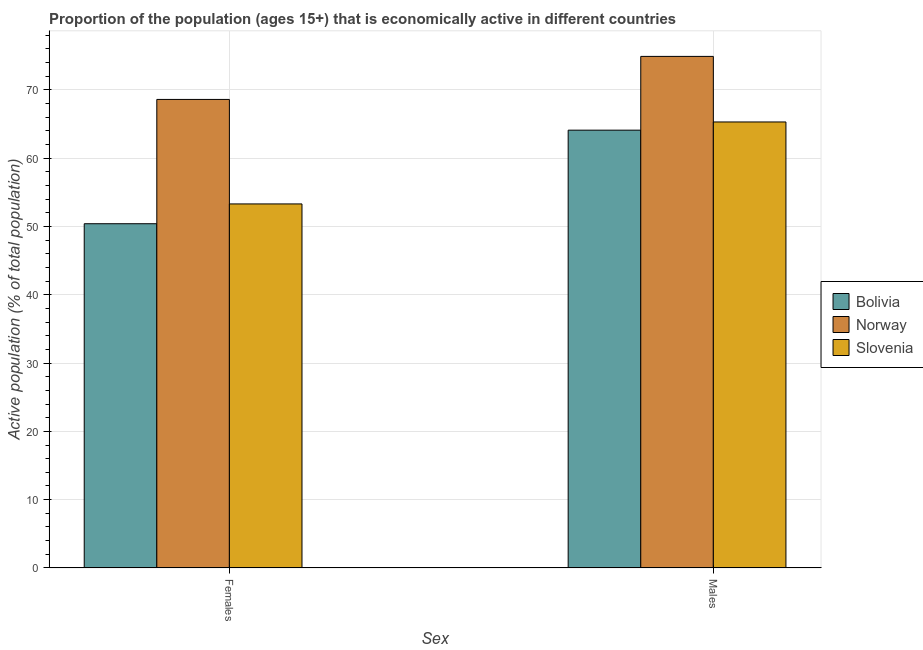How many groups of bars are there?
Your answer should be compact. 2. Are the number of bars per tick equal to the number of legend labels?
Provide a short and direct response. Yes. How many bars are there on the 2nd tick from the left?
Your answer should be compact. 3. What is the label of the 1st group of bars from the left?
Your response must be concise. Females. What is the percentage of economically active female population in Slovenia?
Give a very brief answer. 53.3. Across all countries, what is the maximum percentage of economically active female population?
Ensure brevity in your answer.  68.6. Across all countries, what is the minimum percentage of economically active female population?
Keep it short and to the point. 50.4. In which country was the percentage of economically active male population maximum?
Keep it short and to the point. Norway. In which country was the percentage of economically active female population minimum?
Provide a succinct answer. Bolivia. What is the total percentage of economically active female population in the graph?
Ensure brevity in your answer.  172.3. What is the difference between the percentage of economically active female population in Slovenia and that in Norway?
Offer a very short reply. -15.3. What is the difference between the percentage of economically active female population in Bolivia and the percentage of economically active male population in Norway?
Your answer should be compact. -24.5. What is the average percentage of economically active male population per country?
Ensure brevity in your answer.  68.1. What is the difference between the percentage of economically active male population and percentage of economically active female population in Bolivia?
Provide a short and direct response. 13.7. In how many countries, is the percentage of economically active female population greater than 52 %?
Make the answer very short. 2. What is the ratio of the percentage of economically active female population in Slovenia to that in Bolivia?
Your answer should be very brief. 1.06. Is the percentage of economically active female population in Bolivia less than that in Slovenia?
Keep it short and to the point. Yes. In how many countries, is the percentage of economically active male population greater than the average percentage of economically active male population taken over all countries?
Your answer should be compact. 1. What does the 3rd bar from the left in Males represents?
Provide a succinct answer. Slovenia. What does the 2nd bar from the right in Males represents?
Your response must be concise. Norway. How many countries are there in the graph?
Your answer should be very brief. 3. What is the difference between two consecutive major ticks on the Y-axis?
Offer a terse response. 10. Are the values on the major ticks of Y-axis written in scientific E-notation?
Provide a succinct answer. No. Does the graph contain grids?
Make the answer very short. Yes. What is the title of the graph?
Keep it short and to the point. Proportion of the population (ages 15+) that is economically active in different countries. Does "Peru" appear as one of the legend labels in the graph?
Provide a succinct answer. No. What is the label or title of the X-axis?
Offer a very short reply. Sex. What is the label or title of the Y-axis?
Provide a short and direct response. Active population (% of total population). What is the Active population (% of total population) of Bolivia in Females?
Your answer should be compact. 50.4. What is the Active population (% of total population) of Norway in Females?
Provide a short and direct response. 68.6. What is the Active population (% of total population) of Slovenia in Females?
Give a very brief answer. 53.3. What is the Active population (% of total population) of Bolivia in Males?
Keep it short and to the point. 64.1. What is the Active population (% of total population) of Norway in Males?
Your response must be concise. 74.9. What is the Active population (% of total population) in Slovenia in Males?
Provide a short and direct response. 65.3. Across all Sex, what is the maximum Active population (% of total population) in Bolivia?
Your answer should be very brief. 64.1. Across all Sex, what is the maximum Active population (% of total population) in Norway?
Your answer should be very brief. 74.9. Across all Sex, what is the maximum Active population (% of total population) in Slovenia?
Provide a succinct answer. 65.3. Across all Sex, what is the minimum Active population (% of total population) of Bolivia?
Your response must be concise. 50.4. Across all Sex, what is the minimum Active population (% of total population) of Norway?
Your answer should be very brief. 68.6. Across all Sex, what is the minimum Active population (% of total population) in Slovenia?
Your answer should be compact. 53.3. What is the total Active population (% of total population) in Bolivia in the graph?
Offer a terse response. 114.5. What is the total Active population (% of total population) of Norway in the graph?
Offer a terse response. 143.5. What is the total Active population (% of total population) of Slovenia in the graph?
Your response must be concise. 118.6. What is the difference between the Active population (% of total population) in Bolivia in Females and that in Males?
Make the answer very short. -13.7. What is the difference between the Active population (% of total population) of Bolivia in Females and the Active population (% of total population) of Norway in Males?
Ensure brevity in your answer.  -24.5. What is the difference between the Active population (% of total population) of Bolivia in Females and the Active population (% of total population) of Slovenia in Males?
Provide a succinct answer. -14.9. What is the difference between the Active population (% of total population) in Norway in Females and the Active population (% of total population) in Slovenia in Males?
Your answer should be very brief. 3.3. What is the average Active population (% of total population) in Bolivia per Sex?
Give a very brief answer. 57.25. What is the average Active population (% of total population) of Norway per Sex?
Your answer should be very brief. 71.75. What is the average Active population (% of total population) in Slovenia per Sex?
Your answer should be very brief. 59.3. What is the difference between the Active population (% of total population) in Bolivia and Active population (% of total population) in Norway in Females?
Keep it short and to the point. -18.2. What is the difference between the Active population (% of total population) of Bolivia and Active population (% of total population) of Slovenia in Females?
Give a very brief answer. -2.9. What is the difference between the Active population (% of total population) of Norway and Active population (% of total population) of Slovenia in Males?
Give a very brief answer. 9.6. What is the ratio of the Active population (% of total population) in Bolivia in Females to that in Males?
Ensure brevity in your answer.  0.79. What is the ratio of the Active population (% of total population) of Norway in Females to that in Males?
Make the answer very short. 0.92. What is the ratio of the Active population (% of total population) of Slovenia in Females to that in Males?
Offer a very short reply. 0.82. What is the difference between the highest and the second highest Active population (% of total population) of Bolivia?
Provide a short and direct response. 13.7. 